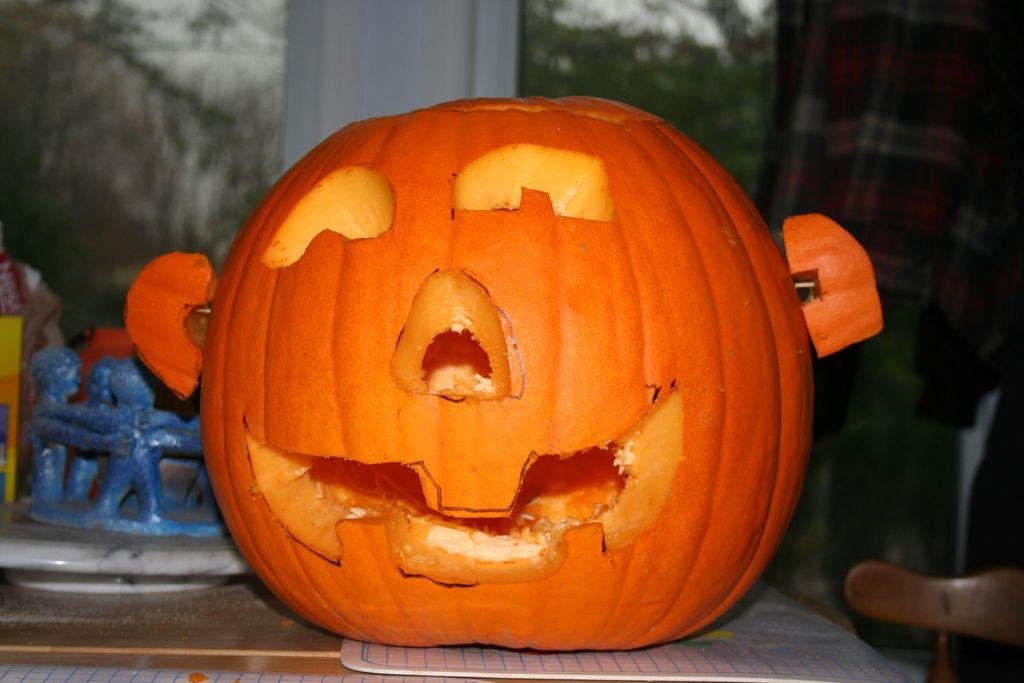What is placed on the table in the image? There is a pumpkin on the table. What can be seen on the right side of the image? There is a cloth on the right side. How would you describe the background of the image? The background of the image is blurry. What is present on the floor in the image? There is a mat in the image. Can you see the person's smile in the image? There is no person present in the image, so it is not possible to see a smile. 